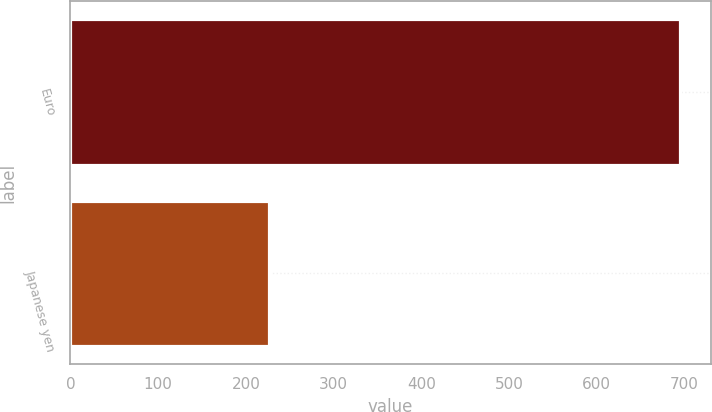Convert chart. <chart><loc_0><loc_0><loc_500><loc_500><bar_chart><fcel>Euro<fcel>Japanese yen<nl><fcel>695<fcel>226<nl></chart> 